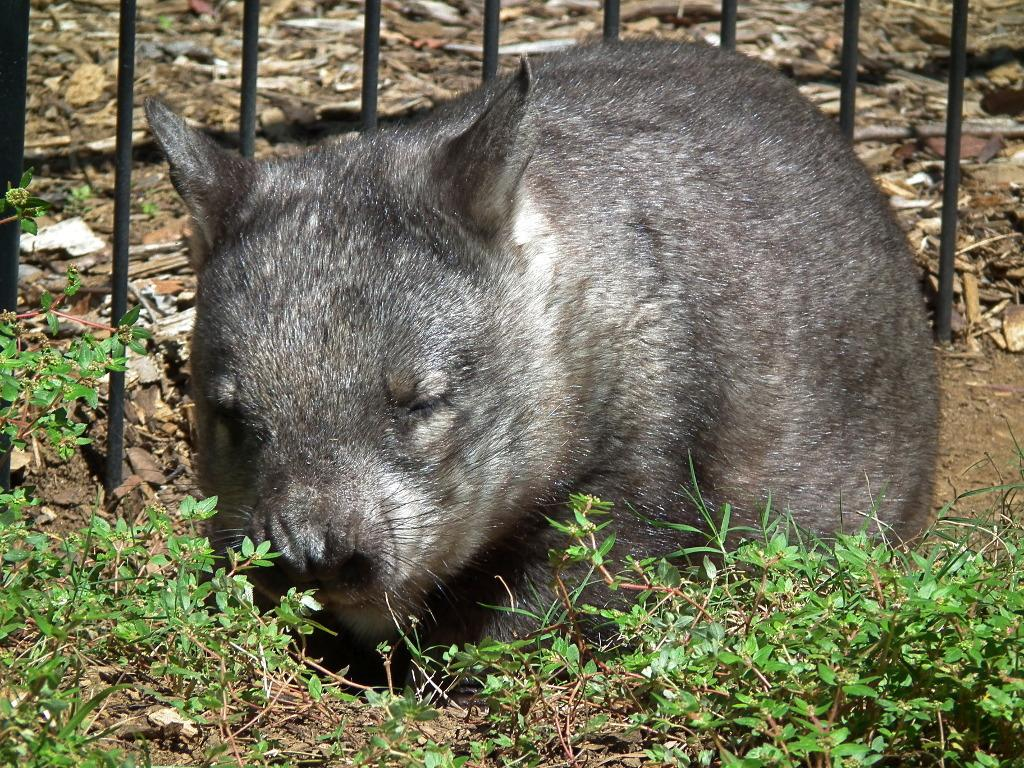What type of living creature is in the image? There is an animal in the image. What is separating the animal from the rest of the scene? There is a fence in the image. What type of vegetation is present in the image? There are plants in the image. What type of jewel is the animal wearing in the image? There is no jewel present in the image, nor is the animal wearing any jewelry. 